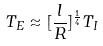<formula> <loc_0><loc_0><loc_500><loc_500>T _ { E } \approx [ \frac { l } { R } ] ^ { \frac { 1 } { 4 } } T _ { I }</formula> 